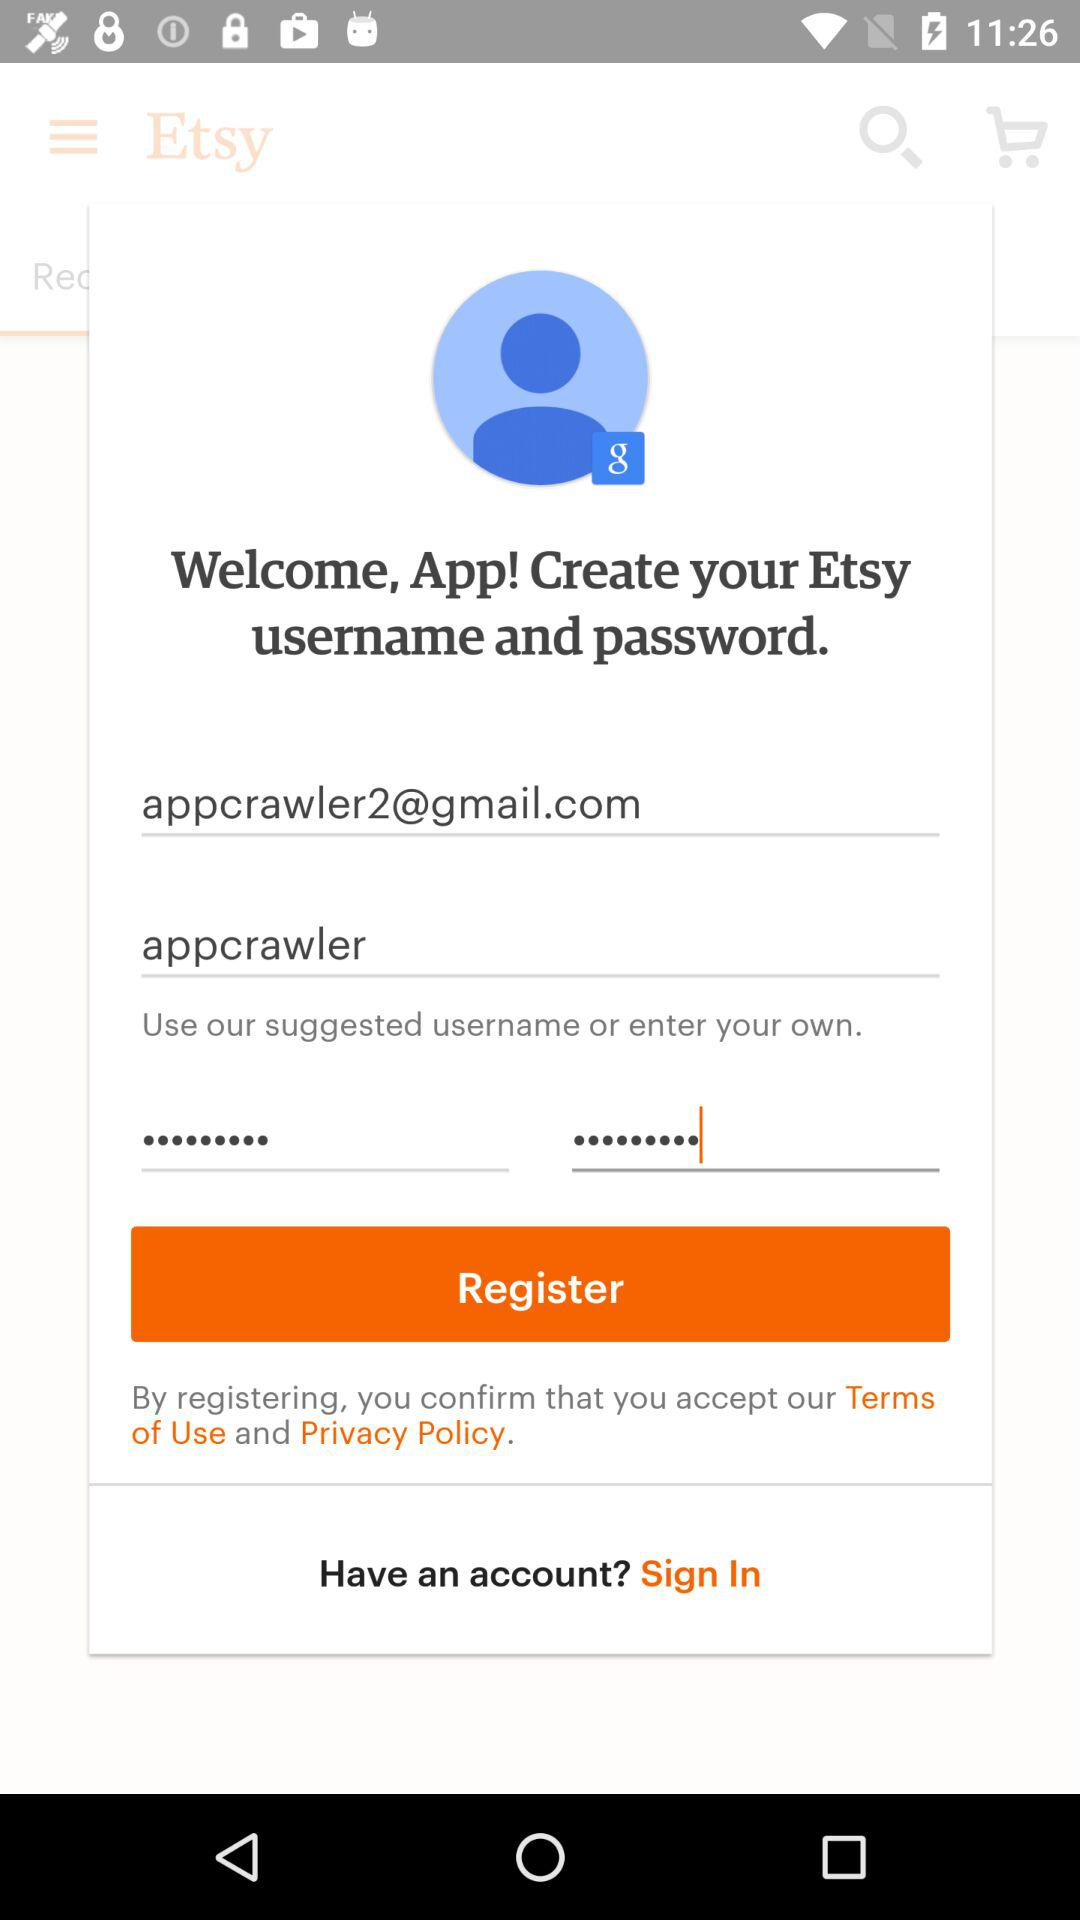How many text inputs are there that have a hint?
Answer the question using a single word or phrase. 2 